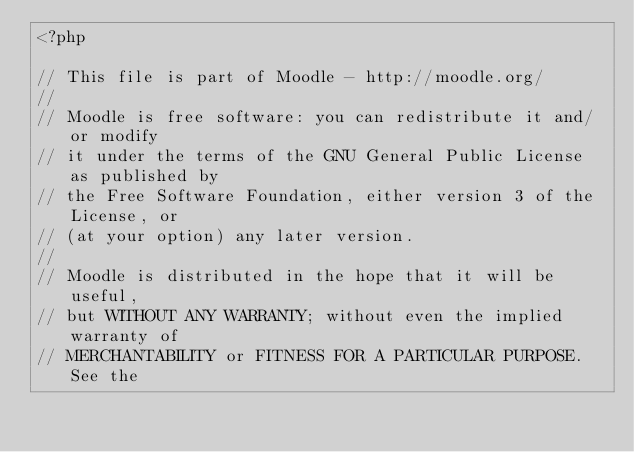<code> <loc_0><loc_0><loc_500><loc_500><_PHP_><?php

// This file is part of Moodle - http://moodle.org/
//
// Moodle is free software: you can redistribute it and/or modify
// it under the terms of the GNU General Public License as published by
// the Free Software Foundation, either version 3 of the License, or
// (at your option) any later version.
//
// Moodle is distributed in the hope that it will be useful,
// but WITHOUT ANY WARRANTY; without even the implied warranty of
// MERCHANTABILITY or FITNESS FOR A PARTICULAR PURPOSE.  See the</code> 